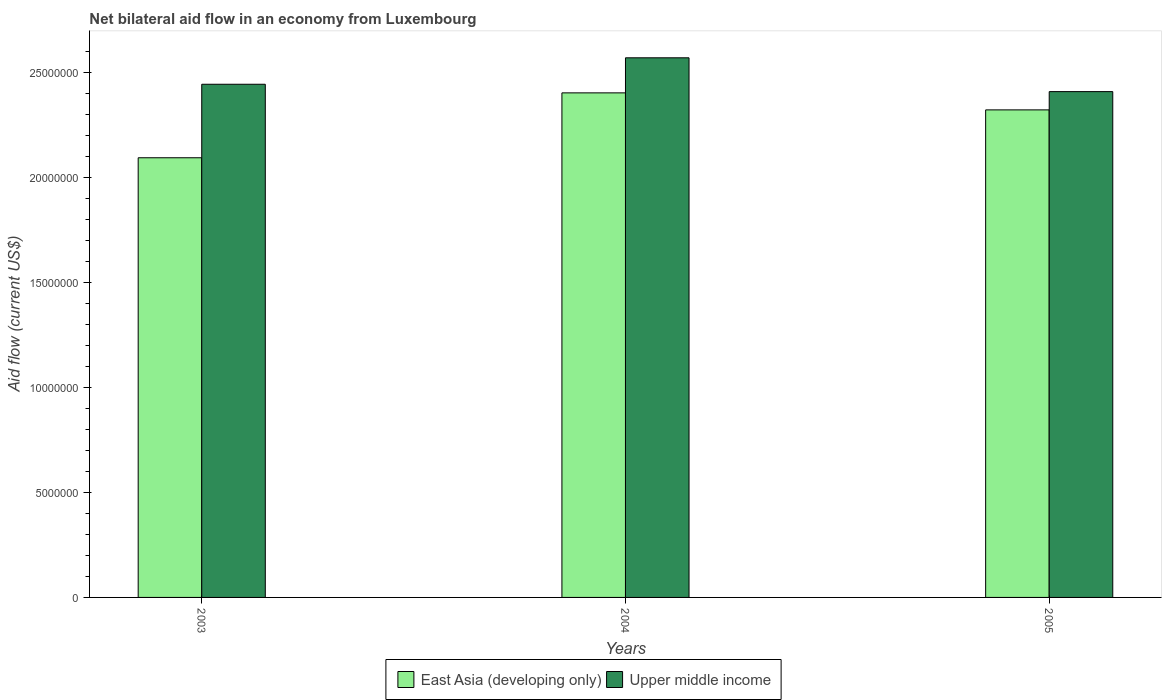How many different coloured bars are there?
Keep it short and to the point. 2. Are the number of bars per tick equal to the number of legend labels?
Provide a succinct answer. Yes. How many bars are there on the 1st tick from the left?
Give a very brief answer. 2. What is the net bilateral aid flow in Upper middle income in 2003?
Ensure brevity in your answer.  2.44e+07. Across all years, what is the maximum net bilateral aid flow in East Asia (developing only)?
Keep it short and to the point. 2.40e+07. Across all years, what is the minimum net bilateral aid flow in East Asia (developing only)?
Your answer should be very brief. 2.09e+07. In which year was the net bilateral aid flow in Upper middle income maximum?
Offer a terse response. 2004. What is the total net bilateral aid flow in Upper middle income in the graph?
Keep it short and to the point. 7.42e+07. What is the difference between the net bilateral aid flow in East Asia (developing only) in 2003 and that in 2004?
Your answer should be very brief. -3.09e+06. What is the difference between the net bilateral aid flow in East Asia (developing only) in 2003 and the net bilateral aid flow in Upper middle income in 2004?
Your response must be concise. -4.76e+06. What is the average net bilateral aid flow in East Asia (developing only) per year?
Provide a short and direct response. 2.27e+07. In the year 2003, what is the difference between the net bilateral aid flow in Upper middle income and net bilateral aid flow in East Asia (developing only)?
Provide a short and direct response. 3.50e+06. What is the ratio of the net bilateral aid flow in Upper middle income in 2003 to that in 2005?
Make the answer very short. 1.01. Is the net bilateral aid flow in East Asia (developing only) in 2004 less than that in 2005?
Make the answer very short. No. Is the difference between the net bilateral aid flow in Upper middle income in 2004 and 2005 greater than the difference between the net bilateral aid flow in East Asia (developing only) in 2004 and 2005?
Make the answer very short. Yes. What is the difference between the highest and the second highest net bilateral aid flow in Upper middle income?
Your answer should be compact. 1.26e+06. What is the difference between the highest and the lowest net bilateral aid flow in Upper middle income?
Provide a succinct answer. 1.61e+06. In how many years, is the net bilateral aid flow in Upper middle income greater than the average net bilateral aid flow in Upper middle income taken over all years?
Give a very brief answer. 1. Is the sum of the net bilateral aid flow in Upper middle income in 2003 and 2004 greater than the maximum net bilateral aid flow in East Asia (developing only) across all years?
Provide a short and direct response. Yes. What does the 2nd bar from the left in 2004 represents?
Keep it short and to the point. Upper middle income. What does the 2nd bar from the right in 2005 represents?
Ensure brevity in your answer.  East Asia (developing only). Are all the bars in the graph horizontal?
Offer a terse response. No. How many years are there in the graph?
Your answer should be compact. 3. Are the values on the major ticks of Y-axis written in scientific E-notation?
Keep it short and to the point. No. Does the graph contain any zero values?
Your answer should be compact. No. How many legend labels are there?
Make the answer very short. 2. What is the title of the graph?
Your answer should be very brief. Net bilateral aid flow in an economy from Luxembourg. Does "Romania" appear as one of the legend labels in the graph?
Provide a succinct answer. No. What is the label or title of the X-axis?
Provide a short and direct response. Years. What is the label or title of the Y-axis?
Your answer should be very brief. Aid flow (current US$). What is the Aid flow (current US$) of East Asia (developing only) in 2003?
Offer a very short reply. 2.09e+07. What is the Aid flow (current US$) of Upper middle income in 2003?
Offer a very short reply. 2.44e+07. What is the Aid flow (current US$) in East Asia (developing only) in 2004?
Your answer should be compact. 2.40e+07. What is the Aid flow (current US$) in Upper middle income in 2004?
Make the answer very short. 2.57e+07. What is the Aid flow (current US$) of East Asia (developing only) in 2005?
Your answer should be very brief. 2.32e+07. What is the Aid flow (current US$) in Upper middle income in 2005?
Provide a succinct answer. 2.41e+07. Across all years, what is the maximum Aid flow (current US$) in East Asia (developing only)?
Give a very brief answer. 2.40e+07. Across all years, what is the maximum Aid flow (current US$) of Upper middle income?
Your response must be concise. 2.57e+07. Across all years, what is the minimum Aid flow (current US$) in East Asia (developing only)?
Your response must be concise. 2.09e+07. Across all years, what is the minimum Aid flow (current US$) in Upper middle income?
Your answer should be very brief. 2.41e+07. What is the total Aid flow (current US$) in East Asia (developing only) in the graph?
Give a very brief answer. 6.82e+07. What is the total Aid flow (current US$) of Upper middle income in the graph?
Provide a succinct answer. 7.42e+07. What is the difference between the Aid flow (current US$) of East Asia (developing only) in 2003 and that in 2004?
Provide a succinct answer. -3.09e+06. What is the difference between the Aid flow (current US$) in Upper middle income in 2003 and that in 2004?
Offer a terse response. -1.26e+06. What is the difference between the Aid flow (current US$) of East Asia (developing only) in 2003 and that in 2005?
Provide a succinct answer. -2.28e+06. What is the difference between the Aid flow (current US$) in East Asia (developing only) in 2004 and that in 2005?
Your response must be concise. 8.10e+05. What is the difference between the Aid flow (current US$) in Upper middle income in 2004 and that in 2005?
Your answer should be very brief. 1.61e+06. What is the difference between the Aid flow (current US$) of East Asia (developing only) in 2003 and the Aid flow (current US$) of Upper middle income in 2004?
Ensure brevity in your answer.  -4.76e+06. What is the difference between the Aid flow (current US$) in East Asia (developing only) in 2003 and the Aid flow (current US$) in Upper middle income in 2005?
Provide a succinct answer. -3.15e+06. What is the average Aid flow (current US$) of East Asia (developing only) per year?
Keep it short and to the point. 2.27e+07. What is the average Aid flow (current US$) of Upper middle income per year?
Make the answer very short. 2.47e+07. In the year 2003, what is the difference between the Aid flow (current US$) in East Asia (developing only) and Aid flow (current US$) in Upper middle income?
Give a very brief answer. -3.50e+06. In the year 2004, what is the difference between the Aid flow (current US$) in East Asia (developing only) and Aid flow (current US$) in Upper middle income?
Your answer should be very brief. -1.67e+06. In the year 2005, what is the difference between the Aid flow (current US$) of East Asia (developing only) and Aid flow (current US$) of Upper middle income?
Ensure brevity in your answer.  -8.70e+05. What is the ratio of the Aid flow (current US$) in East Asia (developing only) in 2003 to that in 2004?
Your answer should be very brief. 0.87. What is the ratio of the Aid flow (current US$) in Upper middle income in 2003 to that in 2004?
Offer a terse response. 0.95. What is the ratio of the Aid flow (current US$) of East Asia (developing only) in 2003 to that in 2005?
Your answer should be compact. 0.9. What is the ratio of the Aid flow (current US$) in Upper middle income in 2003 to that in 2005?
Provide a succinct answer. 1.01. What is the ratio of the Aid flow (current US$) of East Asia (developing only) in 2004 to that in 2005?
Your answer should be very brief. 1.03. What is the ratio of the Aid flow (current US$) in Upper middle income in 2004 to that in 2005?
Make the answer very short. 1.07. What is the difference between the highest and the second highest Aid flow (current US$) in East Asia (developing only)?
Offer a terse response. 8.10e+05. What is the difference between the highest and the second highest Aid flow (current US$) of Upper middle income?
Your response must be concise. 1.26e+06. What is the difference between the highest and the lowest Aid flow (current US$) in East Asia (developing only)?
Your response must be concise. 3.09e+06. What is the difference between the highest and the lowest Aid flow (current US$) in Upper middle income?
Your response must be concise. 1.61e+06. 